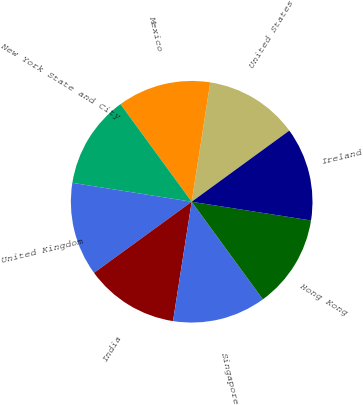Convert chart. <chart><loc_0><loc_0><loc_500><loc_500><pie_chart><fcel>United States<fcel>Mexico<fcel>New York State and City<fcel>United Kingdom<fcel>India<fcel>Singapore<fcel>Hong Kong<fcel>Ireland<nl><fcel>12.52%<fcel>12.49%<fcel>12.47%<fcel>12.52%<fcel>12.51%<fcel>12.5%<fcel>12.49%<fcel>12.5%<nl></chart> 